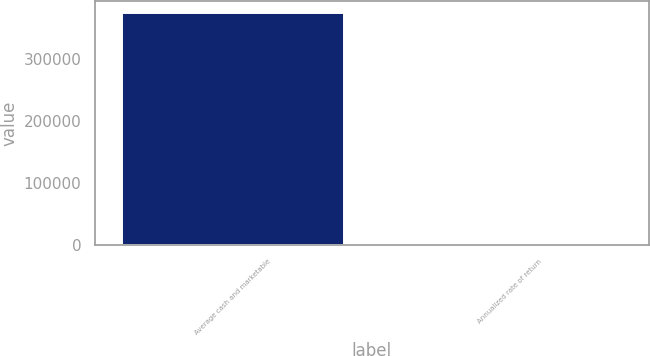<chart> <loc_0><loc_0><loc_500><loc_500><bar_chart><fcel>Average cash and marketable<fcel>Annualized rate of return<nl><fcel>375269<fcel>9.1<nl></chart> 